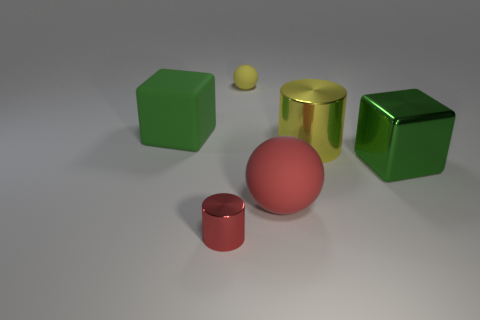Can you describe the lighting in the scene? The lighting of the scene is soft and diffused, casting gentle shadows to the right of the objects, suggesting a light source from the upper left. The light gives the objects a three-dimensional quality and helps to define their shapes. 